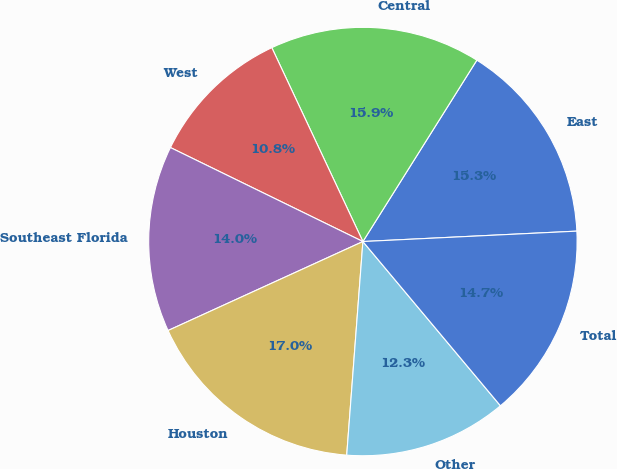Convert chart to OTSL. <chart><loc_0><loc_0><loc_500><loc_500><pie_chart><fcel>East<fcel>Central<fcel>West<fcel>Southeast Florida<fcel>Houston<fcel>Other<fcel>Total<nl><fcel>15.3%<fcel>15.92%<fcel>10.78%<fcel>14.05%<fcel>16.98%<fcel>12.3%<fcel>14.68%<nl></chart> 